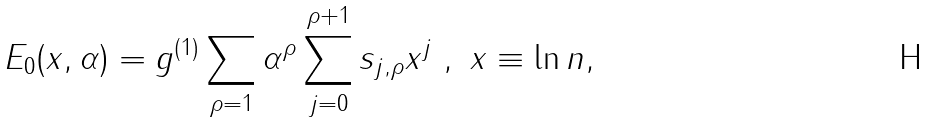<formula> <loc_0><loc_0><loc_500><loc_500>E _ { 0 } ( x , \alpha ) = g ^ { ( 1 ) } \sum _ { \rho = 1 } \alpha ^ { \rho } \sum _ { j = 0 } ^ { \rho + 1 } s _ { j , \rho } x ^ { j } \ , \ x \equiv \ln n ,</formula> 